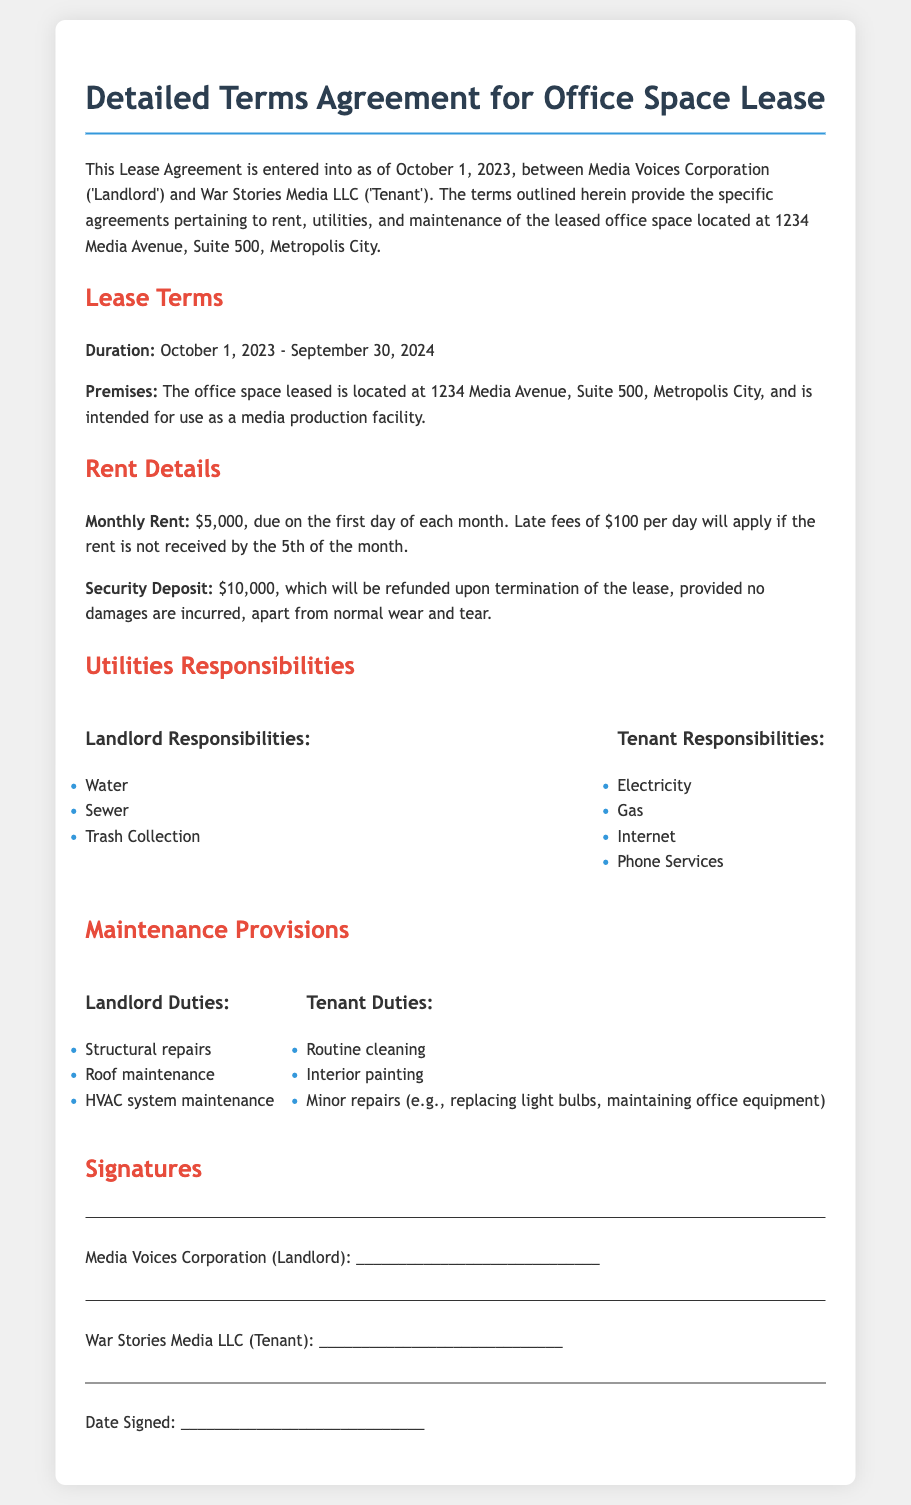What is the effective lease duration? The lease duration is identified in the Lease Terms section, which specifies the start and end dates of the lease.
Answer: October 1, 2023 - September 30, 2024 What is the monthly rent for the office space? The Rent Details section provides the amount due monthly to the landlord for leasing the space.
Answer: $5,000 What is the amount of the security deposit? The Rent Details section mentions the security deposit required prior to taking possession of the leased premises.
Answer: $10,000 Which utilities are the landlord responsible for? The Utilities Responsibilities section outlines the utilities that the landlord manages, which include specific items.
Answer: Water, Sewer, Trash Collection What are the tenant’s responsibilities regarding utilities? The same section lists what the tenant is accountable for in terms of utilities provided to the leased premises.
Answer: Electricity, Gas, Internet, Phone Services Who is responsible for structural repairs? The Maintenance Provisions section specifies the responsibilities of both parties; structural repairs fall under one party's duties.
Answer: Landlord What minor repairs are the tenant responsible for? The Maintenance Provisions outline the specific duties that pertain to minor maintenance, detailing what exactly the tenant handles.
Answer: Minor repairs (e.g., replacing light bulbs, maintaining office equipment) What is the late fee charged for late rent? This information is specified within the Rent Details section, indicating the fee for overdue payments.
Answer: $100 per day When is rent due each month? The Rent Details section explicitly states the date on which the monthly rent must be paid.
Answer: First day of each month 